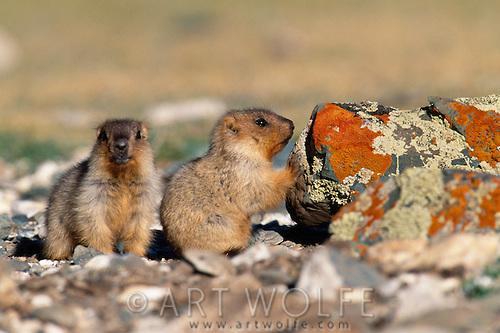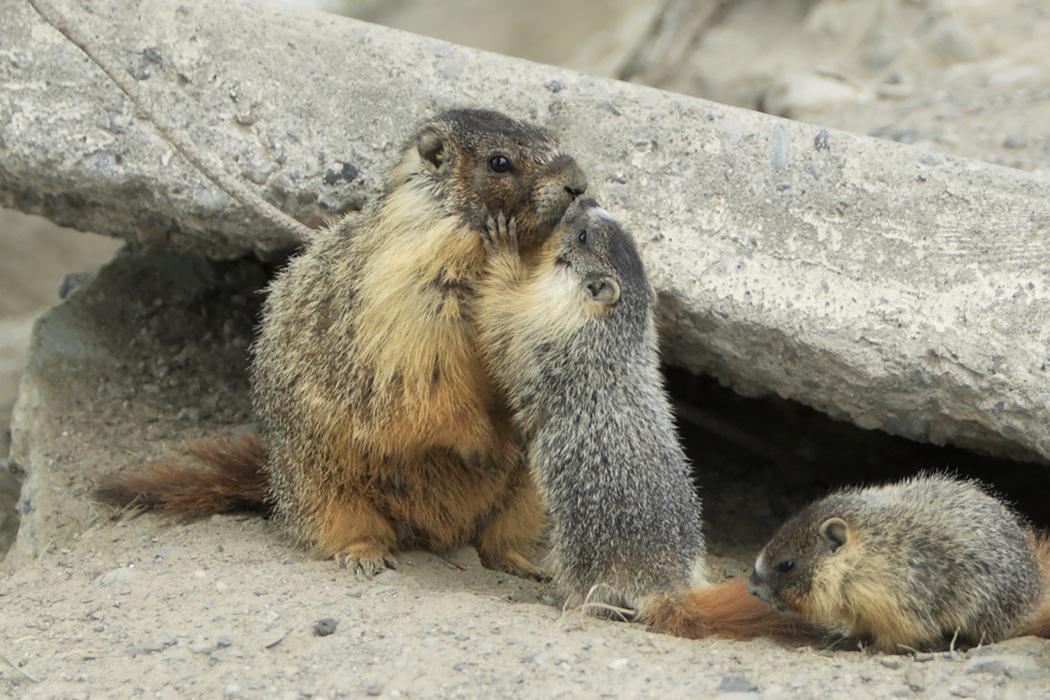The first image is the image on the left, the second image is the image on the right. Considering the images on both sides, is "Each image contains exactly one prairie dog type animal." valid? Answer yes or no. No. The first image is the image on the left, the second image is the image on the right. Given the left and right images, does the statement "There are no less than three animals" hold true? Answer yes or no. Yes. 